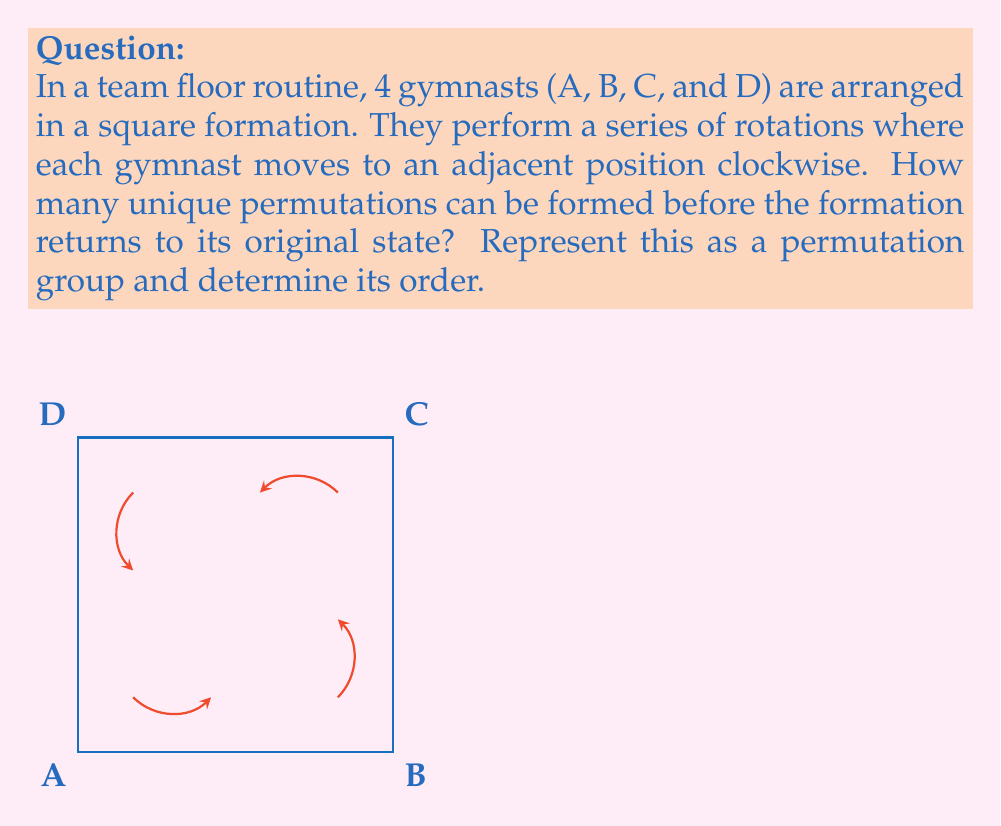What is the answer to this math problem? Let's approach this step-by-step:

1) First, we need to understand the permutation cycle. In each rotation:
   A → B, B → C, C → D, D → A

2) We can represent this as a cycle notation: (A B C D)

3) To find how many unique permutations exist before returning to the original state, we need to apply this permutation repeatedly:

   Original: (A B C D)
   After 1 rotation: (B C D A)
   After 2 rotations: (C D A B)
   After 3 rotations: (D A B C)
   After 4 rotations: (A B C D) - back to original

4) We see that it takes 4 rotations to return to the original state. This means the permutation group has an order of 4.

5) Formally, this permutation group is isomorphic to the cyclic group $C_4$ or $\mathbb{Z}_4$.

6) The elements of this group can be represented as powers of the basic permutation $\sigma = (A B C D)$:

   $\{e, \sigma, \sigma^2, \sigma^3\}$

   where $e$ is the identity permutation and $\sigma^4 = e$

7) This group is abelian (commutative) and has the following properties:
   - Identity: $e$
   - Inverse: $\sigma^{-1} = \sigma^3$
   - Closure: Applying any two permutations in the group results in another permutation in the group
   - Associativity: $(ab)c = a(bc)$ for all elements $a,b,c$ in the group
Answer: The permutation group has order 4 and is isomorphic to $C_4$ or $\mathbb{Z}_4$. 